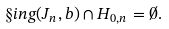Convert formula to latex. <formula><loc_0><loc_0><loc_500><loc_500>\S i n g ( J _ { n } , b ) \cap H _ { 0 , n } = \emptyset .</formula> 